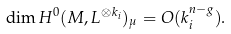Convert formula to latex. <formula><loc_0><loc_0><loc_500><loc_500>\dim H ^ { 0 } ( M , L ^ { \otimes k _ { i } } ) _ { \mu } = O ( k _ { i } ^ { n - g } ) .</formula> 